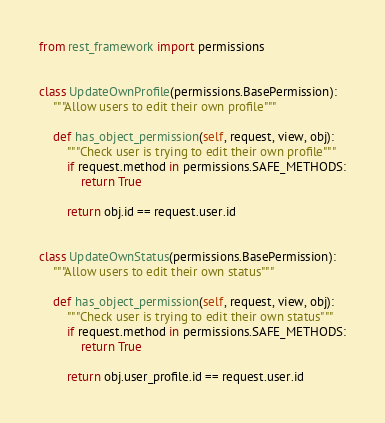Convert code to text. <code><loc_0><loc_0><loc_500><loc_500><_Python_>from rest_framework import permissions


class UpdateOwnProfile(permissions.BasePermission):
    """Allow users to edit their own profile"""

    def has_object_permission(self, request, view, obj):
        """Check user is trying to edit their own profile"""
        if request.method in permissions.SAFE_METHODS:
            return True

        return obj.id == request.user.id


class UpdateOwnStatus(permissions.BasePermission):
    """Allow users to edit their own status"""

    def has_object_permission(self, request, view, obj):
        """Check user is trying to edit their own status"""
        if request.method in permissions.SAFE_METHODS:
            return True

        return obj.user_profile.id == request.user.id
</code> 